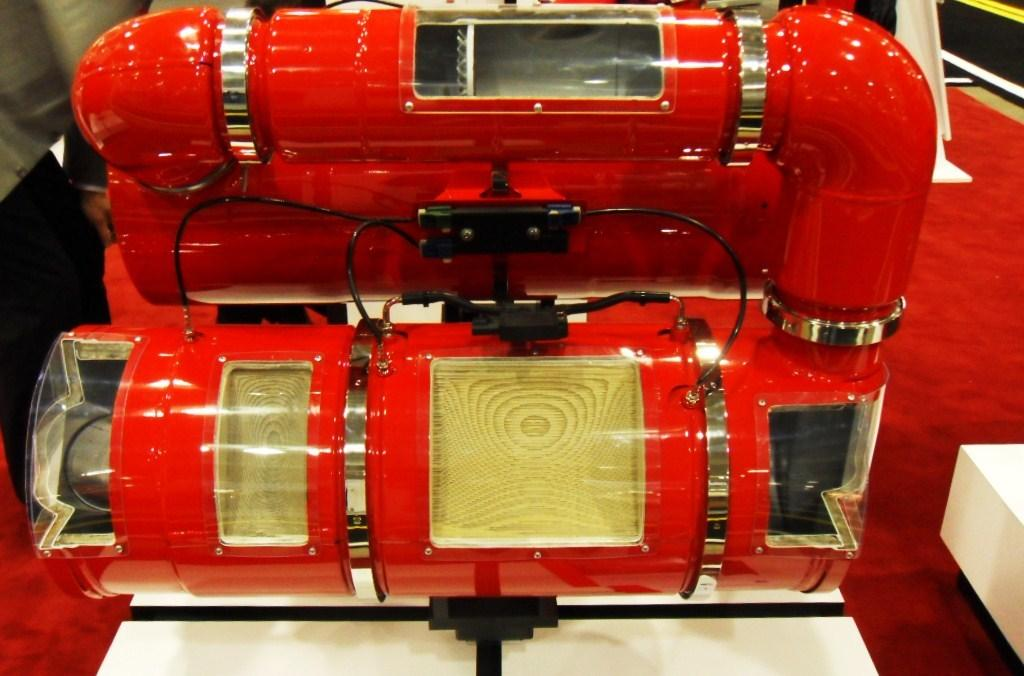What is the main object on the table in the image? There is a machine on a table in the image. What type of flooring is visible in the image? There is a red carpet in the image. What type of berry is being used to care for the machine in the image? There is no berry present in the image, and the machine does not require care in the way described. 